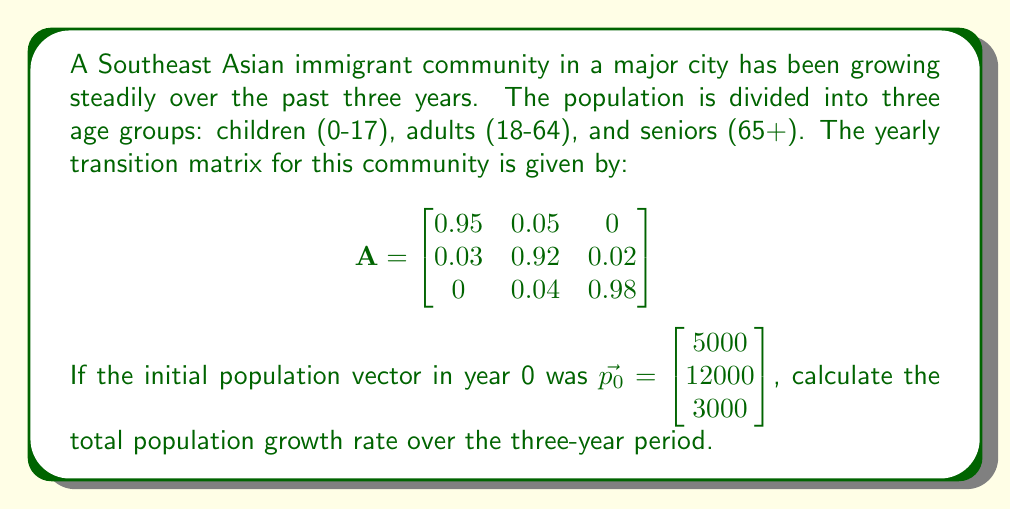Provide a solution to this math problem. To solve this problem, we'll follow these steps:

1) First, we need to calculate the population vector for each year using matrix multiplication:

   Year 1: $\vec{p_1} = A\vec{p_0}$
   Year 2: $\vec{p_2} = A\vec{p_1} = A^2\vec{p_0}$
   Year 3: $\vec{p_3} = A\vec{p_2} = A^3\vec{p_0}$

2) Let's calculate $A^3$:

   $$A^3 = \begin{bmatrix}
   0.857375 & 0.131625 & 0.011 \\
   0.084375 & 0.784125 & 0.131500 \\
   0.005625 & 0.115875 & 0.878500
   \end{bmatrix}$$

3) Now we can calculate $\vec{p_3}$:

   $$\vec{p_3} = A^3\vec{p_0} = \begin{bmatrix}
   0.857375 & 0.131625 & 0.011 \\
   0.084375 & 0.784125 & 0.131500 \\
   0.005625 & 0.115875 & 0.878500
   \end{bmatrix} \begin{bmatrix} 5000 \\ 12000 \\ 3000 \end{bmatrix}$$

   $$\vec{p_3} = \begin{bmatrix} 5786.875 \\ 12106.875 \\ 3106.250 \end{bmatrix}$$

4) The total initial population was:
   $5000 + 12000 + 3000 = 20000$

5) The total population after 3 years is:
   $5786.875 + 12106.875 + 3106.250 = 21000$

6) To calculate the growth rate over 3 years:
   Growth rate = $\frac{\text{Final Population} - \text{Initial Population}}{\text{Initial Population}} \times 100\%$
   
   $= \frac{21000 - 20000}{20000} \times 100\% = 5\%$

7) To get the annual growth rate, we use the compound annual growth rate formula:
   $(1 + r)^3 = 1.05$
   $r = \sqrt[3]{1.05} - 1 \approx 0.01639 = 1.639\%$
Answer: 1.639% 